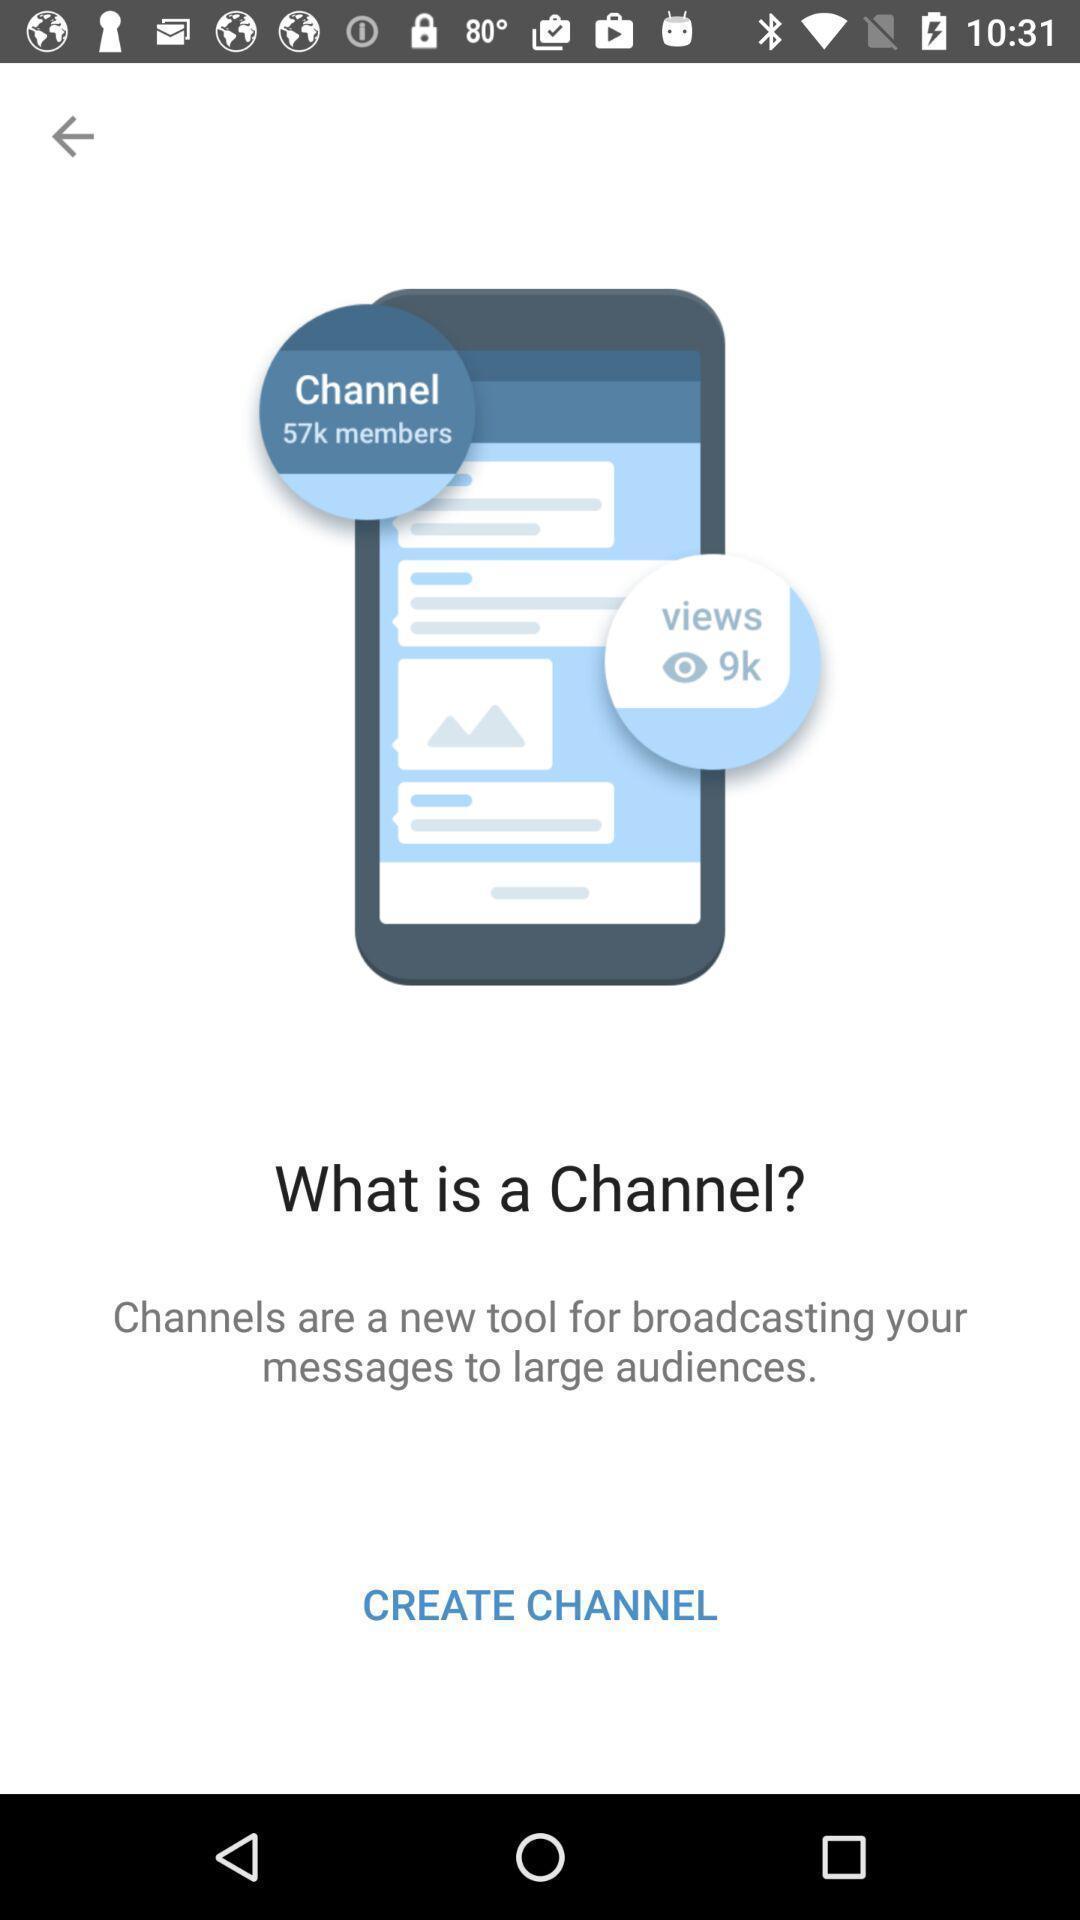Tell me what you see in this picture. Welcome page showing the option to create channel. 